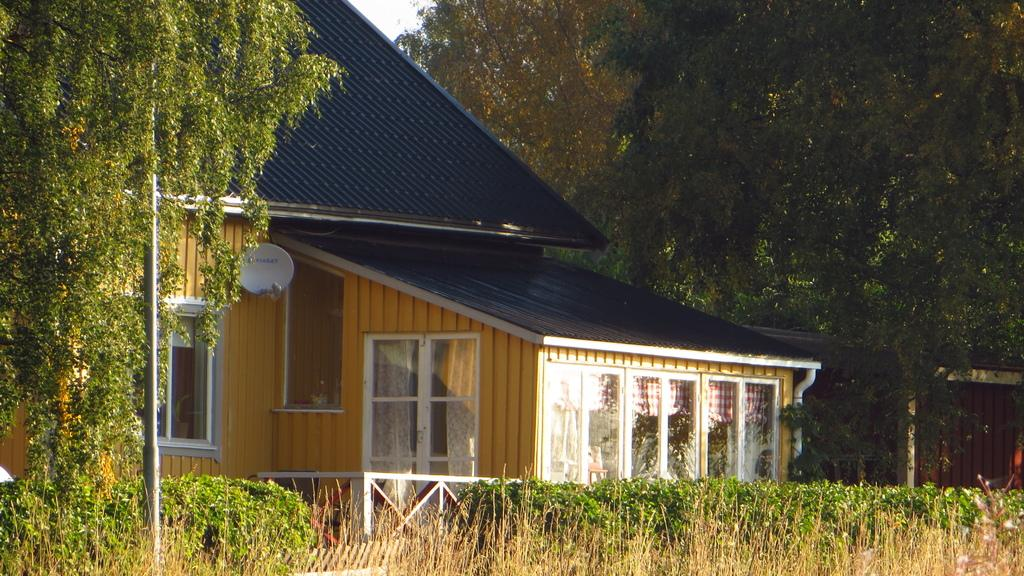What is the main structure visible in the image? There is a house in the image. What is located in front of the house? There is a pole in the image. What is behind the house? There is a wall behind the house in the image. What can be seen in the background of the image? There are trees and the sky visible in the background of the image. What is the rate of the sweater in the image? There is no sweater present in the image, so it is not possible to determine a rate. 